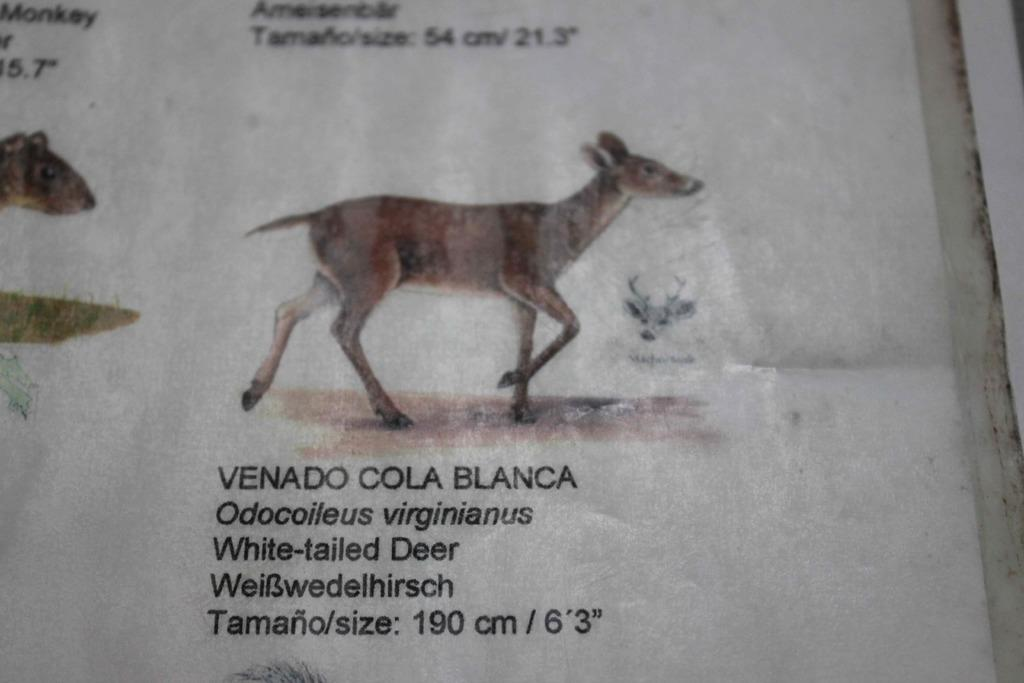What is present in the image that can be written or drawn on? There is a paper in the image that can be written or drawn on. What type of living creatures can be seen in the image? There are animals in the image. What can be found on the paper in the image? There is text in the image. What color is the background of the image? The background of the image is white in color. Can you see any pigs flying in the image? There are no pigs or flying pigs present in the image. Is there an airplane visible in the image? No, there is no airplane present in the image. 